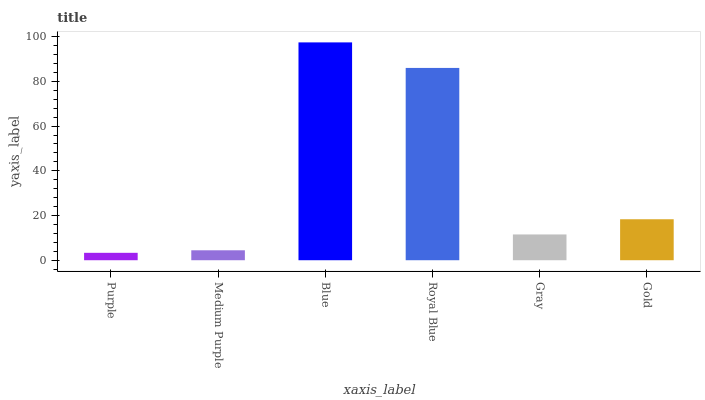Is Purple the minimum?
Answer yes or no. Yes. Is Blue the maximum?
Answer yes or no. Yes. Is Medium Purple the minimum?
Answer yes or no. No. Is Medium Purple the maximum?
Answer yes or no. No. Is Medium Purple greater than Purple?
Answer yes or no. Yes. Is Purple less than Medium Purple?
Answer yes or no. Yes. Is Purple greater than Medium Purple?
Answer yes or no. No. Is Medium Purple less than Purple?
Answer yes or no. No. Is Gold the high median?
Answer yes or no. Yes. Is Gray the low median?
Answer yes or no. Yes. Is Medium Purple the high median?
Answer yes or no. No. Is Royal Blue the low median?
Answer yes or no. No. 